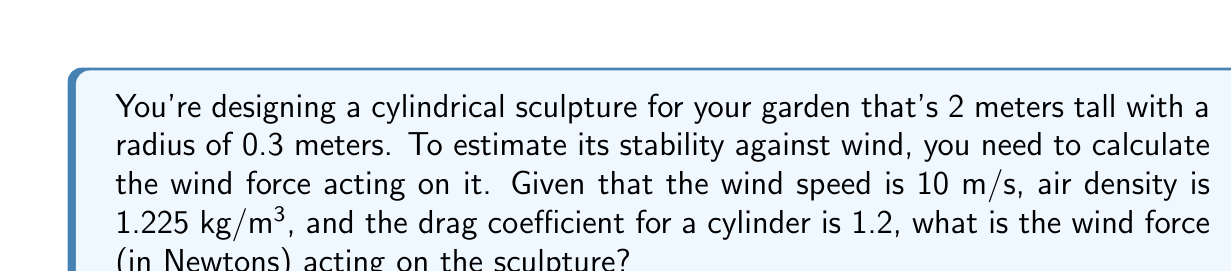Show me your answer to this math problem. To calculate the wind force on the cylindrical sculpture, we'll use the drag equation:

$$F = \frac{1}{2} \rho v^2 C_d A$$

Where:
$F$ = Wind force (N)
$\rho$ = Air density (kg/m³)
$v$ = Wind speed (m/s)
$C_d$ = Drag coefficient
$A$ = Projected area (m²)

Step 1: Calculate the projected area of the cylinder.
The projected area is the height multiplied by the diameter:
$$A = 2 \text{ m} \times (2 \times 0.3 \text{ m}) = 1.2 \text{ m}^2$$

Step 2: Plug all values into the drag equation:
$$F = \frac{1}{2} \times 1.225 \text{ kg/m}^3 \times (10 \text{ m/s})^2 \times 1.2 \times 1.2 \text{ m}^2$$

Step 3: Calculate the result:
$$F = 0.5 \times 1.225 \times 100 \times 1.2 \times 1.2 = 88.2 \text{ N}$$

Therefore, the wind force acting on the cylindrical sculpture is approximately 88.2 Newtons.
Answer: 88.2 N 